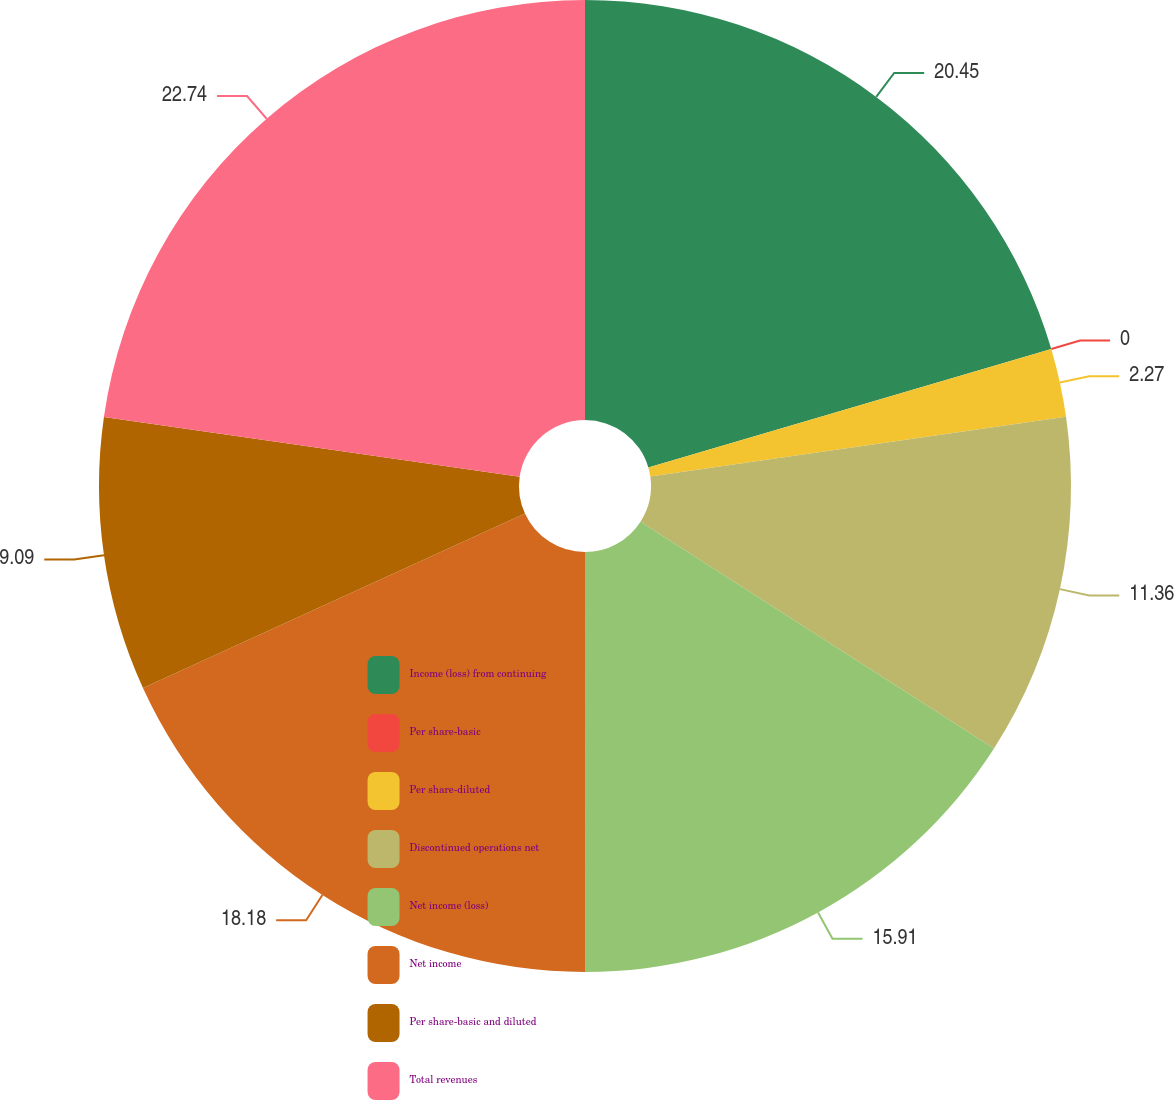Convert chart to OTSL. <chart><loc_0><loc_0><loc_500><loc_500><pie_chart><fcel>Income (loss) from continuing<fcel>Per share-basic<fcel>Per share-diluted<fcel>Discontinued operations net<fcel>Net income (loss)<fcel>Net income<fcel>Per share-basic and diluted<fcel>Total revenues<nl><fcel>20.45%<fcel>0.0%<fcel>2.27%<fcel>11.36%<fcel>15.91%<fcel>18.18%<fcel>9.09%<fcel>22.73%<nl></chart> 